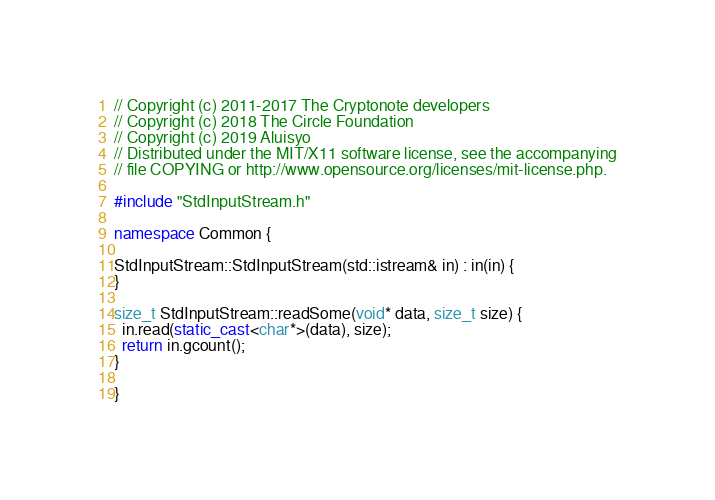<code> <loc_0><loc_0><loc_500><loc_500><_C++_>// Copyright (c) 2011-2017 The Cryptonote developers
// Copyright (c) 2018 The Circle Foundation
// Copyright (c) 2019 Aluisyo
// Distributed under the MIT/X11 software license, see the accompanying
// file COPYING or http://www.opensource.org/licenses/mit-license.php.

#include "StdInputStream.h"

namespace Common {

StdInputStream::StdInputStream(std::istream& in) : in(in) {
}

size_t StdInputStream::readSome(void* data, size_t size) {
  in.read(static_cast<char*>(data), size);
  return in.gcount();
}

}
</code> 